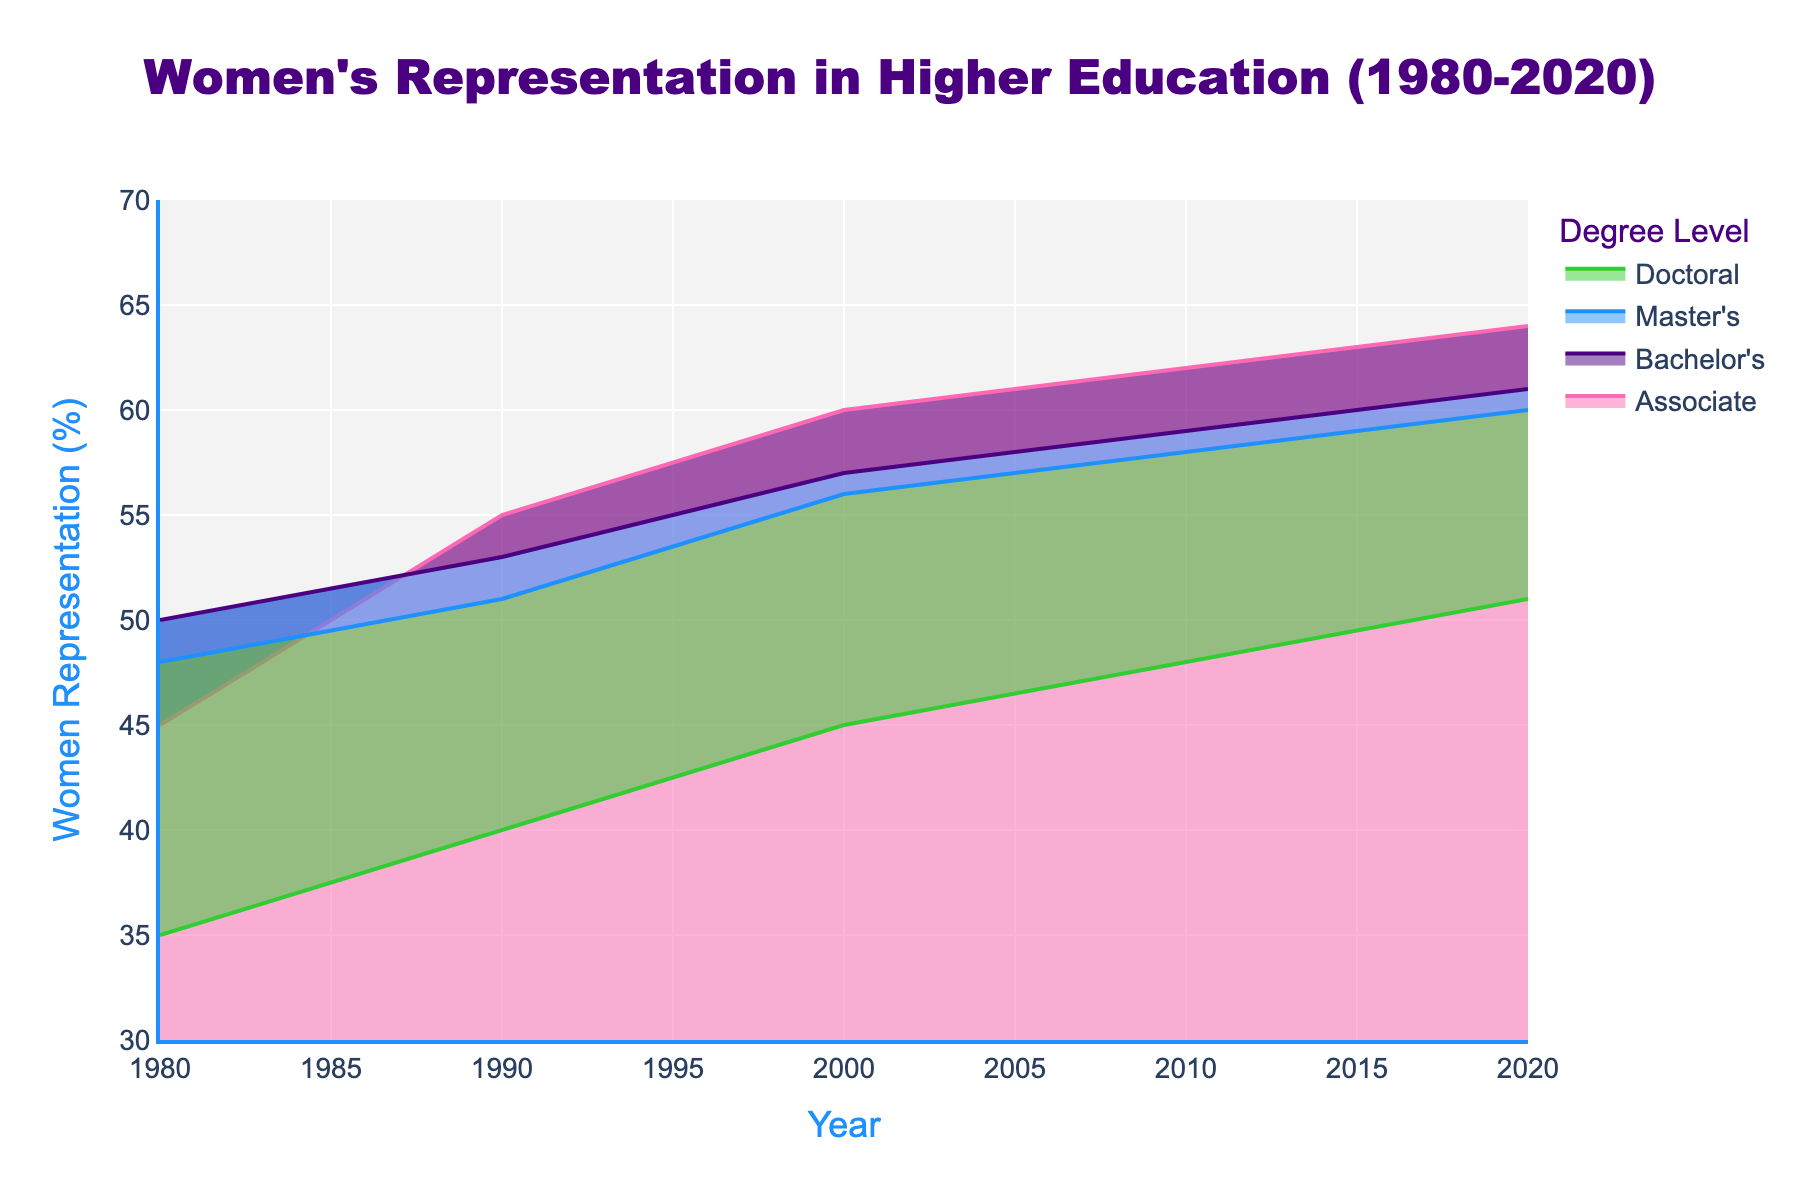What is the title of the chart? The chart title is typically found at the top of the figure. In this case, it is written in large font size and prominent position, making it easily identifiable.
Answer: Women's Representation in Higher Education (1980-2020) What is the representation of women in Associate Degrees in 2020? Look at the point corresponding to 2020 on the x-axis and trace it upwards to the Associate Degrees line. Read the y-axis value at this point, which represents the percentage of women's representation.
Answer: 64% Which degree level had the lowest women's representation in 1980? Look at the points on the x-axis corresponding to 1980 for each degree level and compare the y-axis values. The lowest y-axis value represents the degree level with the lowest women's representation.
Answer: Doctoral How did the women's representation in Bachelor's degrees change from 1980 to 2020? To find the change, subtract the 1980 value from the 2020 value for Bachelor's degrees. The data points show: 61% (2020) - 50% (1980).
Answer: 11% Which degree level shows the most consistent increase in women's representation over time? Observe the lines for each degree level and identify the one with the smoothest and steady upward trend from 1980 to 2020.
Answer: Associate What is the approximate average increase in women’s representation for Master's Degrees per decade? To find the average increase per decade, calculate the differences between 1980, 1990, 2000, 2010, and 2020 values, then divide the total increase by the number of decades. (51-48 + 56-51 + 58-56 + 60-58) / 4
Answer: 3% Which degree had the largest percentage point increase in women’s representation between 1980 and 2020? Calculate the percentage increase for each degree by subtracting the 1980 value from the 2020 value. Compare the results to determine the maximum increase. Associate: 64-45, Bachelor’s: 61-50, Master’s: 60-48, Doctoral: 51-35.
Answer: Associate How does women’s representation in doctoral degrees in 1990 compare to that in master’s degrees in 2000? Locate the values on the y-axis for the relevant years and degree levels: Doctoral in 1990 (40%) and Master’s in 2000 (56%), then compare the two values.
Answer: Master's (56%) is higher What was the trend in women’s representation for doctoral degrees from 2000 to 2020? Trace the line corresponding to Doctoral degrees from the year 2000 to 2020, and observe whether it inclines, declines, or stays flat. Report the direction of the trend.
Answer: Increasing 